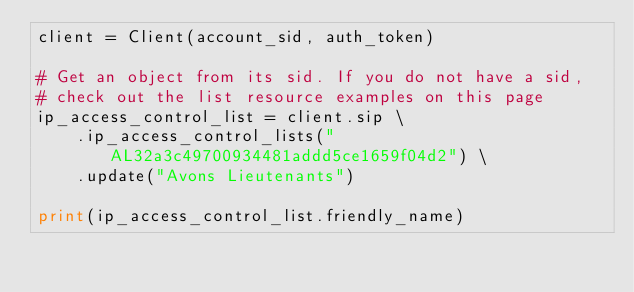<code> <loc_0><loc_0><loc_500><loc_500><_Python_>client = Client(account_sid, auth_token)

# Get an object from its sid. If you do not have a sid,
# check out the list resource examples on this page
ip_access_control_list = client.sip \
    .ip_access_control_lists("AL32a3c49700934481addd5ce1659f04d2") \
    .update("Avons Lieutenants")

print(ip_access_control_list.friendly_name)
</code> 